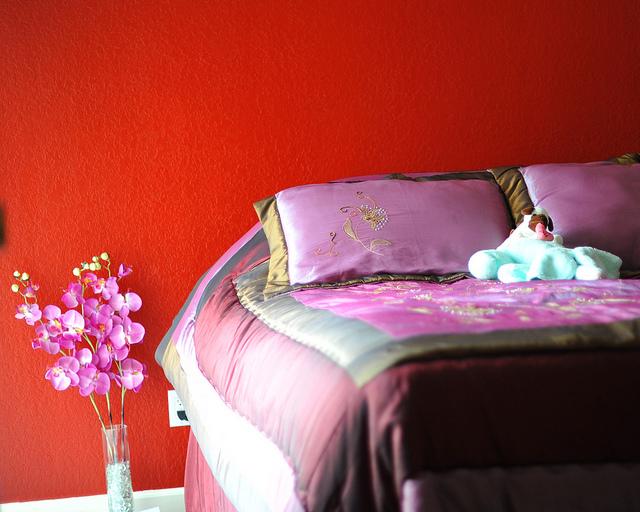What color is the wall?
Answer briefly. Red. Are there flowers in the room?
Answer briefly. Yes. What color is the bedding?
Quick response, please. Purple. 